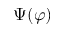<formula> <loc_0><loc_0><loc_500><loc_500>\Psi ( \varphi )</formula> 